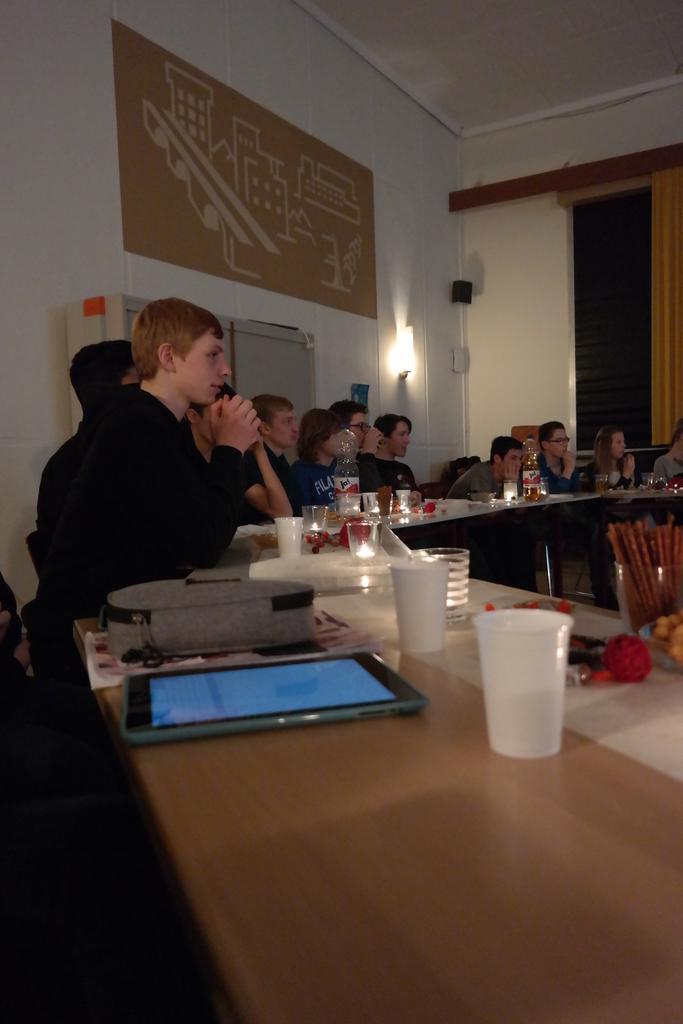Can you describe this image briefly? In this image there are group of people who are sitting on a chair in front of them there is one table, on the table there are cups, one mobile, and bag and some plates are there on the table and on the top there is a ceiling. On the left side there is a wall, on the wall there is one poster on the right side there is one window. 